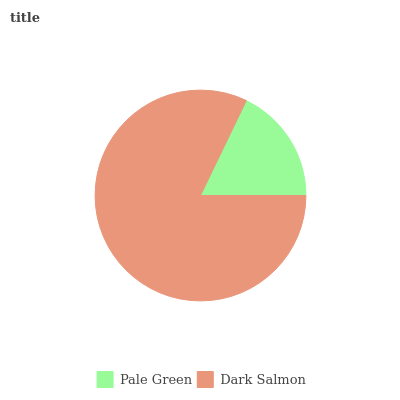Is Pale Green the minimum?
Answer yes or no. Yes. Is Dark Salmon the maximum?
Answer yes or no. Yes. Is Dark Salmon the minimum?
Answer yes or no. No. Is Dark Salmon greater than Pale Green?
Answer yes or no. Yes. Is Pale Green less than Dark Salmon?
Answer yes or no. Yes. Is Pale Green greater than Dark Salmon?
Answer yes or no. No. Is Dark Salmon less than Pale Green?
Answer yes or no. No. Is Dark Salmon the high median?
Answer yes or no. Yes. Is Pale Green the low median?
Answer yes or no. Yes. Is Pale Green the high median?
Answer yes or no. No. Is Dark Salmon the low median?
Answer yes or no. No. 